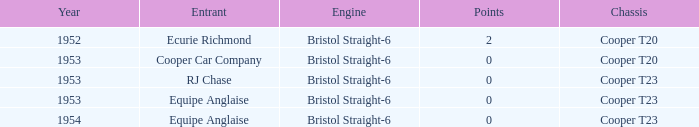Which of the biggest points numbers had a year more recent than 1953? 0.0. 